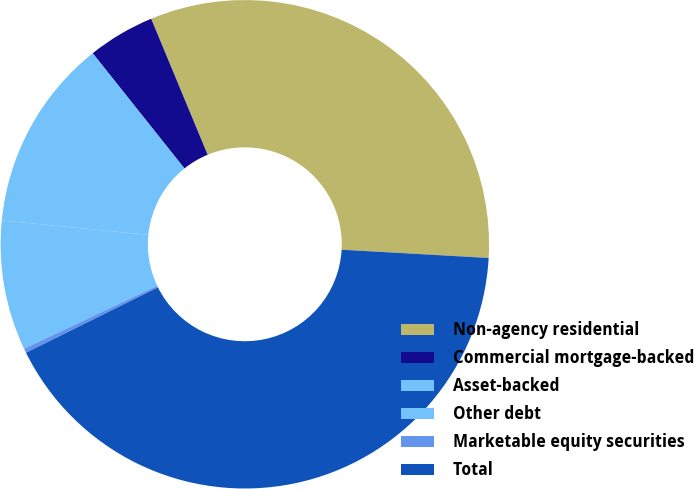<chart> <loc_0><loc_0><loc_500><loc_500><pie_chart><fcel>Non-agency residential<fcel>Commercial mortgage-backed<fcel>Asset-backed<fcel>Other debt<fcel>Marketable equity securities<fcel>Total<nl><fcel>32.16%<fcel>4.44%<fcel>12.74%<fcel>8.59%<fcel>0.29%<fcel>41.79%<nl></chart> 